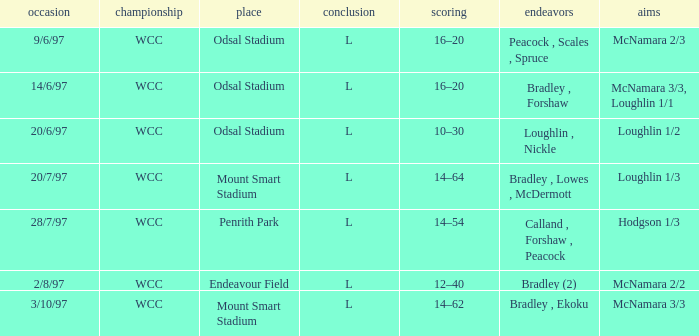What were the tries on 14/6/97? Bradley , Forshaw. 